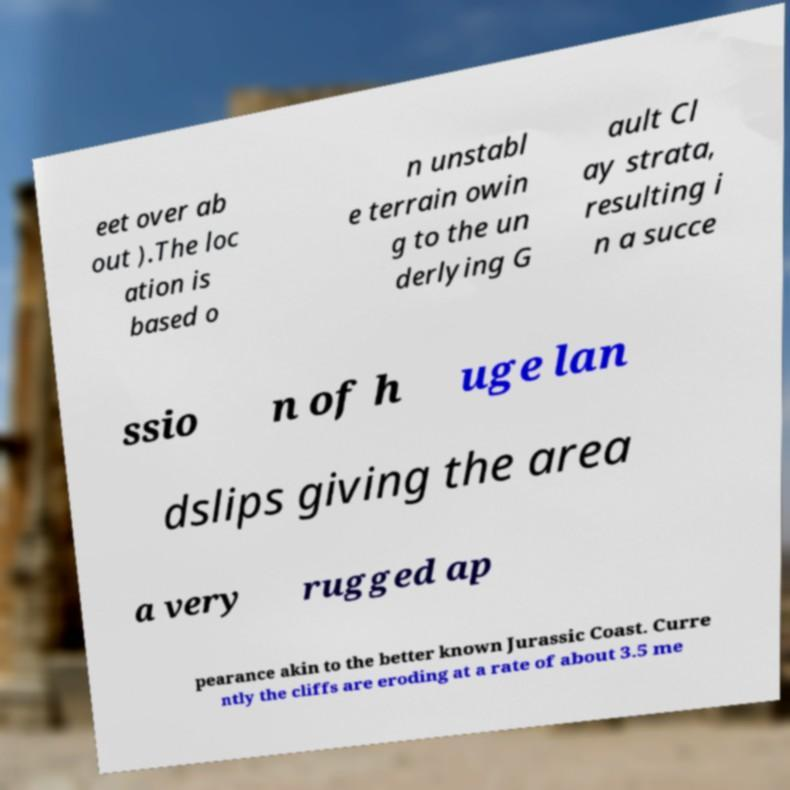There's text embedded in this image that I need extracted. Can you transcribe it verbatim? eet over ab out ).The loc ation is based o n unstabl e terrain owin g to the un derlying G ault Cl ay strata, resulting i n a succe ssio n of h uge lan dslips giving the area a very rugged ap pearance akin to the better known Jurassic Coast. Curre ntly the cliffs are eroding at a rate of about 3.5 me 